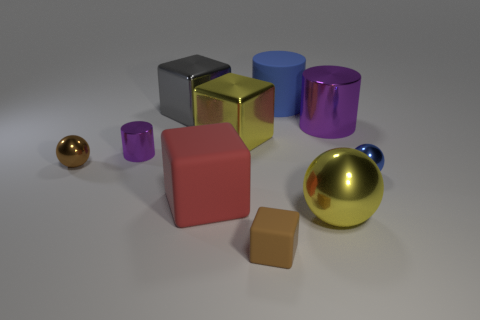Subtract all cubes. How many objects are left? 6 Add 4 tiny metal spheres. How many tiny metal spheres are left? 6 Add 3 green metal cubes. How many green metal cubes exist? 3 Subtract 0 yellow cylinders. How many objects are left? 10 Subtract all big purple rubber balls. Subtract all big metal cylinders. How many objects are left? 9 